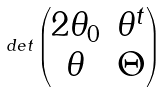Convert formula to latex. <formula><loc_0><loc_0><loc_500><loc_500>d e t \begin{pmatrix} 2 \theta _ { 0 } & \theta ^ { t } \\ \theta & \Theta \\ \end{pmatrix}</formula> 